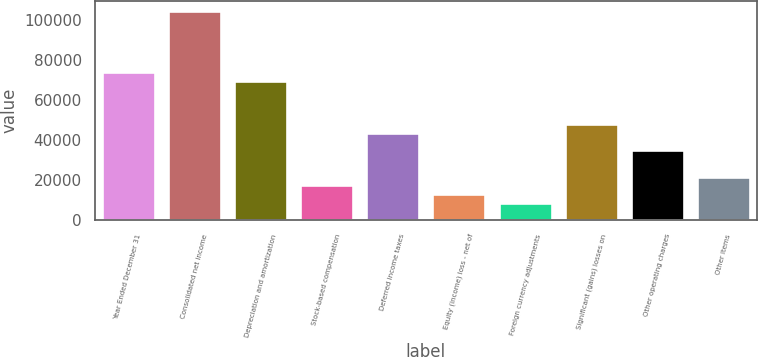Convert chart to OTSL. <chart><loc_0><loc_0><loc_500><loc_500><bar_chart><fcel>Year Ended December 31<fcel>Consolidated net income<fcel>Depreciation and amortization<fcel>Stock-based compensation<fcel>Deferred income taxes<fcel>Equity (income) loss - net of<fcel>Foreign currency adjustments<fcel>Significant (gains) losses on<fcel>Other operating charges<fcel>Other items<nl><fcel>73810.6<fcel>104196<fcel>69469.8<fcel>17380.2<fcel>43425<fcel>13039.4<fcel>8698.6<fcel>47765.8<fcel>34743.4<fcel>21721<nl></chart> 